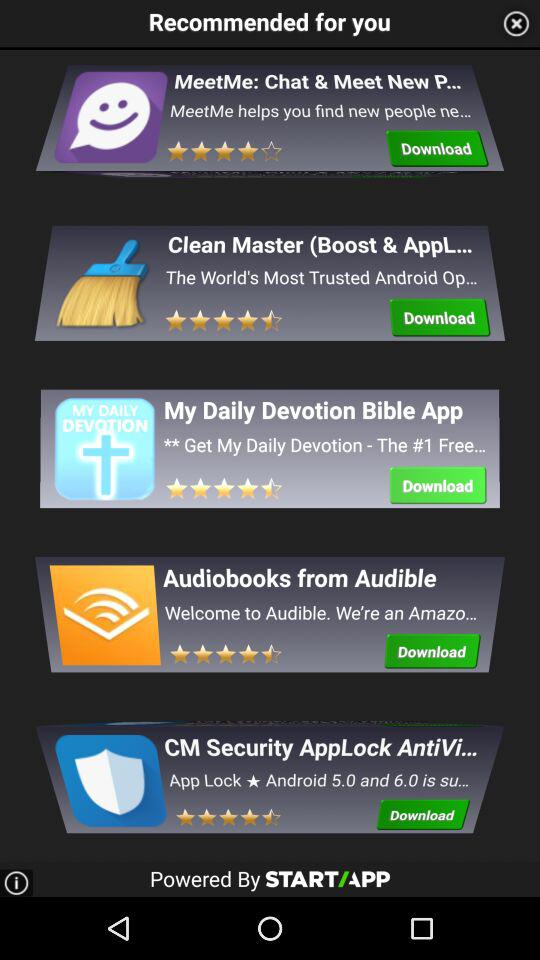What are the ratings of the My Daily Devotion Bible App? The ratings are 4.5 stars. 